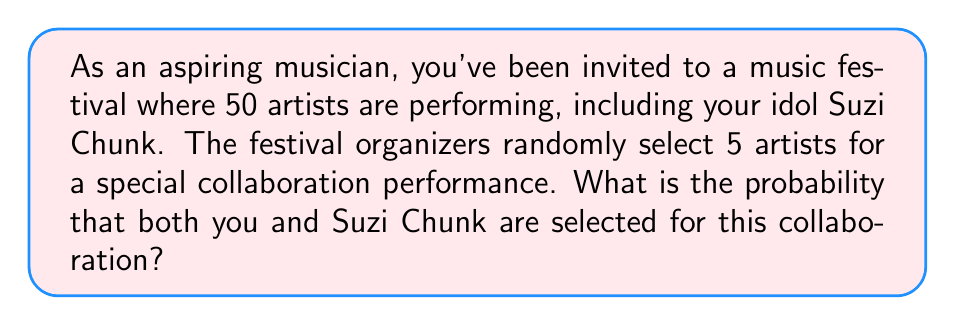Provide a solution to this math problem. Let's approach this step-by-step:

1) First, we need to calculate the total number of ways to select 5 artists from 50. This is a combination problem, denoted as $\binom{50}{5}$ or $C(50,5)$.

   $$\binom{50}{5} = \frac{50!}{5!(50-5)!} = \frac{50!}{5!45!} = 2,118,760$$

2) Now, we need to calculate the number of ways to select both you and Suzi Chunk, plus 3 other artists. This is equivalent to selecting 3 artists from the remaining 48 (50 - 2).

   $$\binom{48}{3} = \frac{48!}{3!(48-3)!} = \frac{48!}{3!45!} = 17,296$$

3) The probability is the number of favorable outcomes divided by the total number of possible outcomes:

   $$P(\text{You and Suzi selected}) = \frac{\text{Number of ways to select you, Suzi, and 3 others}}{\text{Total number of ways to select 5 artists}}$$

   $$P(\text{You and Suzi selected}) = \frac{17,296}{2,118,760}$$

4) Simplifying this fraction:

   $$P(\text{You and Suzi selected}) = \frac{17,296}{2,118,760} = \frac{1}{122.5} \approx 0.00816$$
Answer: $\frac{1}{122.5}$ or approximately 0.00816 